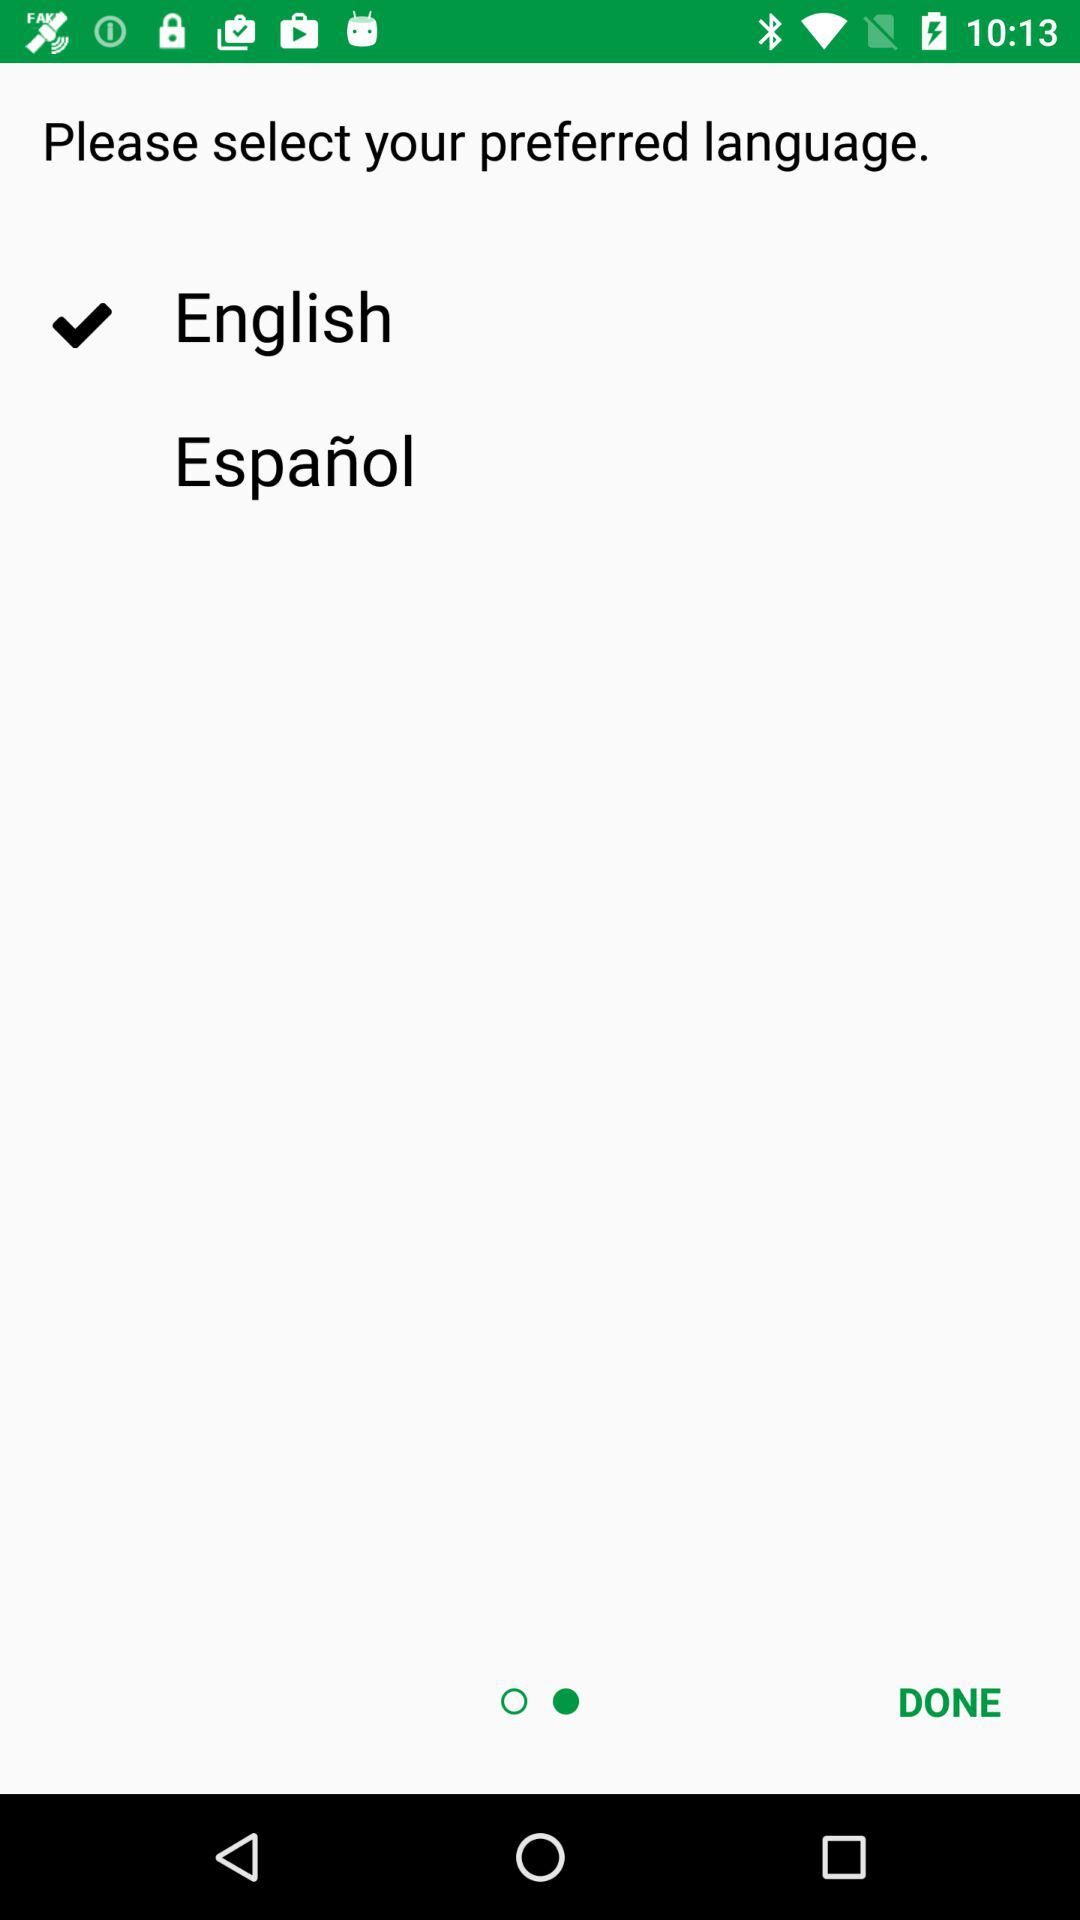How many languages are available for selection?
Answer the question using a single word or phrase. 2 